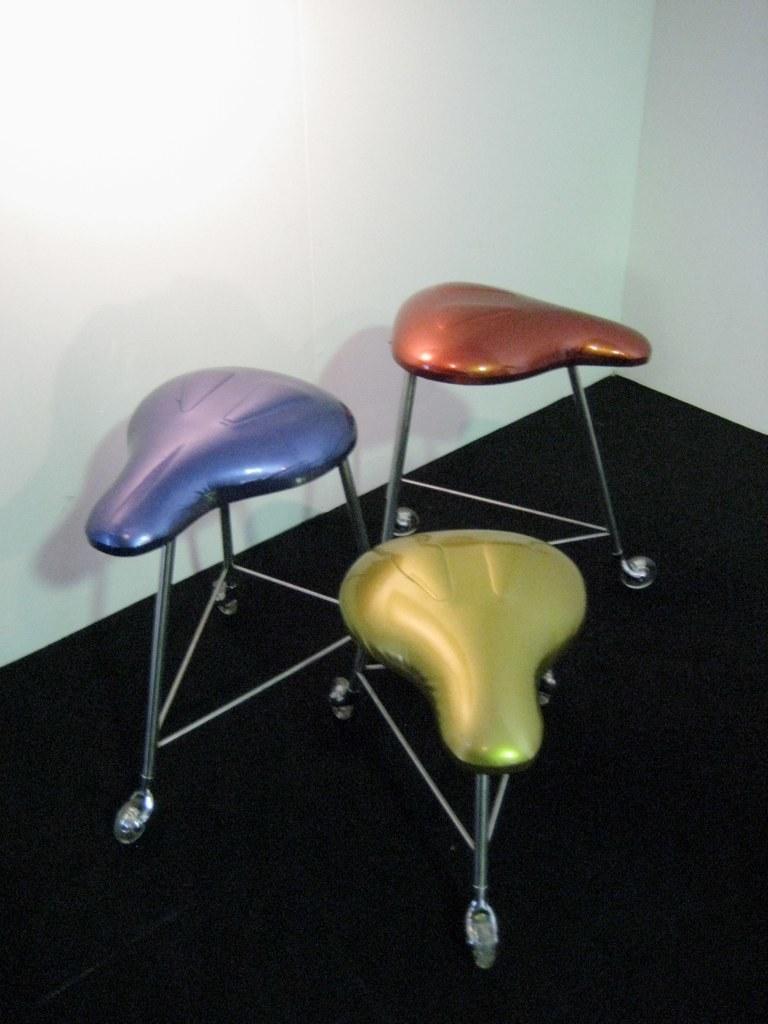Can you describe this image briefly? These are the three chairs with the wheels attached to it. The floor is black in color. This is the wall. 